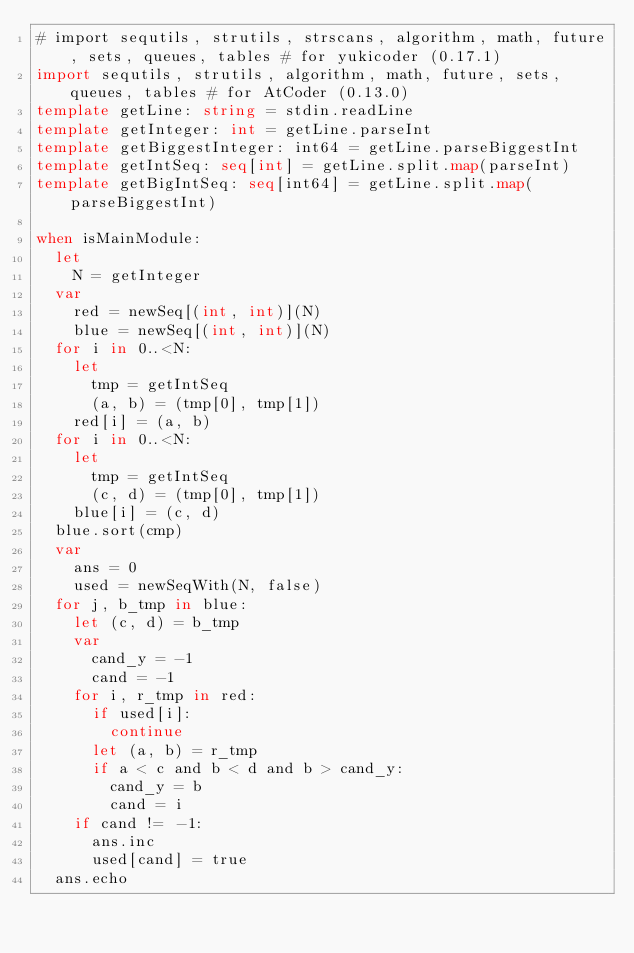Convert code to text. <code><loc_0><loc_0><loc_500><loc_500><_Nim_># import sequtils, strutils, strscans, algorithm, math, future, sets, queues, tables # for yukicoder (0.17.1)
import sequtils, strutils, algorithm, math, future, sets, queues, tables # for AtCoder (0.13.0)
template getLine: string = stdin.readLine
template getInteger: int = getLine.parseInt
template getBiggestInteger: int64 = getLine.parseBiggestInt
template getIntSeq: seq[int] = getLine.split.map(parseInt)
template getBigIntSeq: seq[int64] = getLine.split.map(parseBiggestInt)

when isMainModule:
  let
    N = getInteger
  var
    red = newSeq[(int, int)](N)
    blue = newSeq[(int, int)](N)
  for i in 0..<N:
    let
      tmp = getIntSeq
      (a, b) = (tmp[0], tmp[1])
    red[i] = (a, b)
  for i in 0..<N:
    let
      tmp = getIntSeq
      (c, d) = (tmp[0], tmp[1])
    blue[i] = (c, d)
  blue.sort(cmp)
  var
    ans = 0
    used = newSeqWith(N, false)
  for j, b_tmp in blue:
    let (c, d) = b_tmp
    var
      cand_y = -1
      cand = -1
    for i, r_tmp in red:
      if used[i]:
        continue
      let (a, b) = r_tmp
      if a < c and b < d and b > cand_y:
        cand_y = b
        cand = i
    if cand != -1:
      ans.inc
      used[cand] = true
  ans.echo
</code> 